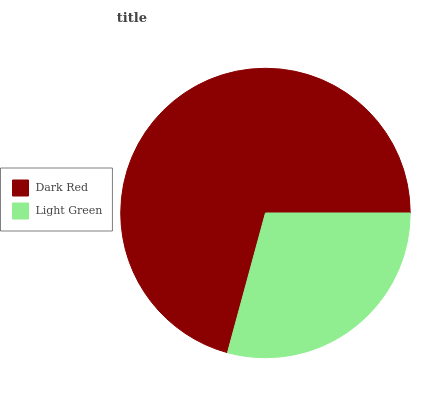Is Light Green the minimum?
Answer yes or no. Yes. Is Dark Red the maximum?
Answer yes or no. Yes. Is Light Green the maximum?
Answer yes or no. No. Is Dark Red greater than Light Green?
Answer yes or no. Yes. Is Light Green less than Dark Red?
Answer yes or no. Yes. Is Light Green greater than Dark Red?
Answer yes or no. No. Is Dark Red less than Light Green?
Answer yes or no. No. Is Dark Red the high median?
Answer yes or no. Yes. Is Light Green the low median?
Answer yes or no. Yes. Is Light Green the high median?
Answer yes or no. No. Is Dark Red the low median?
Answer yes or no. No. 